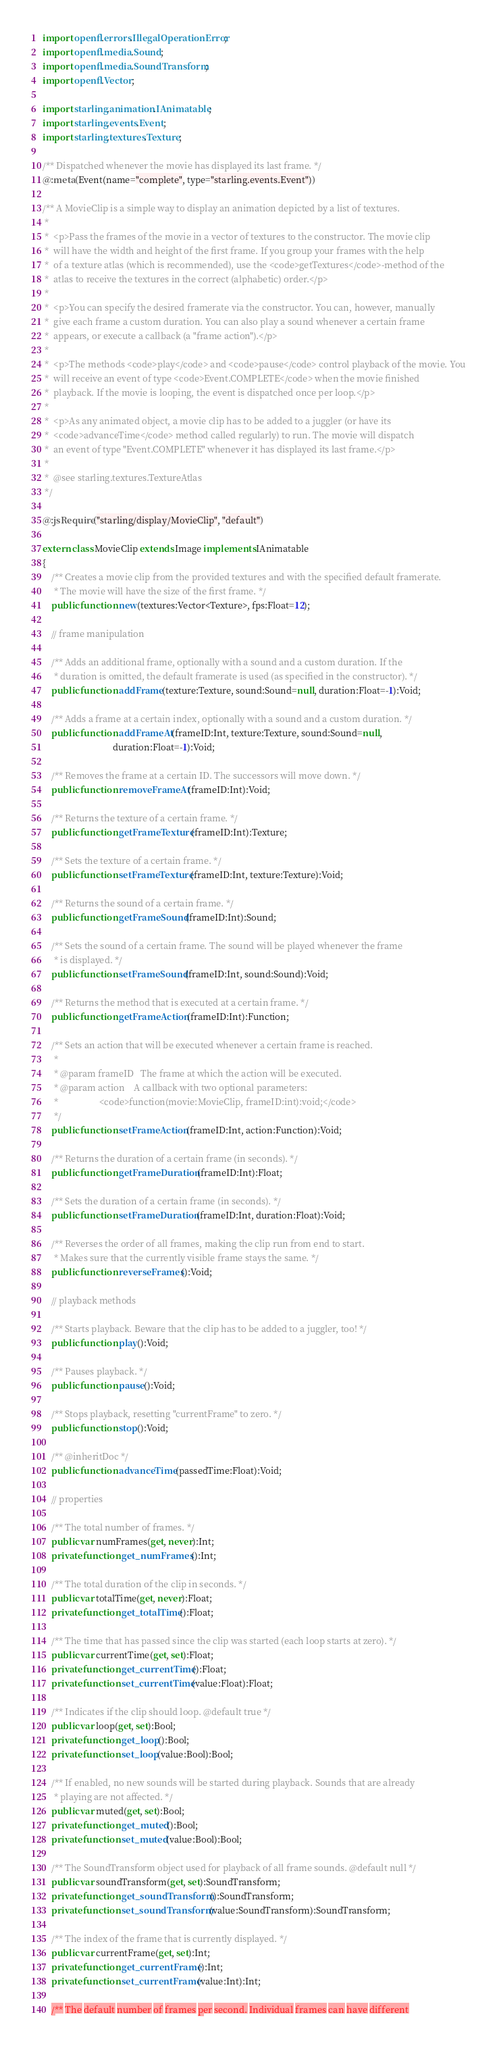<code> <loc_0><loc_0><loc_500><loc_500><_Haxe_>import openfl.errors.IllegalOperationError;
import openfl.media.Sound;
import openfl.media.SoundTransform;
import openfl.Vector;

import starling.animation.IAnimatable;
import starling.events.Event;
import starling.textures.Texture;

/** Dispatched whenever the movie has displayed its last frame. */
@:meta(Event(name="complete", type="starling.events.Event"))

/** A MovieClip is a simple way to display an animation depicted by a list of textures.
 *  
 *  <p>Pass the frames of the movie in a vector of textures to the constructor. The movie clip 
 *  will have the width and height of the first frame. If you group your frames with the help 
 *  of a texture atlas (which is recommended), use the <code>getTextures</code>-method of the 
 *  atlas to receive the textures in the correct (alphabetic) order.</p> 
 *  
 *  <p>You can specify the desired framerate via the constructor. You can, however, manually 
 *  give each frame a custom duration. You can also play a sound whenever a certain frame 
 *  appears, or execute a callback (a "frame action").</p>
 *  
 *  <p>The methods <code>play</code> and <code>pause</code> control playback of the movie. You
 *  will receive an event of type <code>Event.COMPLETE</code> when the movie finished
 *  playback. If the movie is looping, the event is dispatched once per loop.</p>
 *  
 *  <p>As any animated object, a movie clip has to be added to a juggler (or have its 
 *  <code>advanceTime</code> method called regularly) to run. The movie will dispatch 
 *  an event of type "Event.COMPLETE" whenever it has displayed its last frame.</p>
 *  
 *  @see starling.textures.TextureAtlas
 */    

@:jsRequire("starling/display/MovieClip", "default")

extern class MovieClip extends Image implements IAnimatable
{
    /** Creates a movie clip from the provided textures and with the specified default framerate.
     * The movie will have the size of the first frame. */  
    public function new(textures:Vector<Texture>, fps:Float=12);
    
    // frame manipulation
    
    /** Adds an additional frame, optionally with a sound and a custom duration. If the 
     * duration is omitted, the default framerate is used (as specified in the constructor). */   
    public function addFrame(texture:Texture, sound:Sound=null, duration:Float=-1):Void;
    
    /** Adds a frame at a certain index, optionally with a sound and a custom duration. */
    public function addFrameAt(frameID:Int, texture:Texture, sound:Sound=null, 
                               duration:Float=-1):Void;
    
    /** Removes the frame at a certain ID. The successors will move down. */
    public function removeFrameAt(frameID:Int):Void;
    
    /** Returns the texture of a certain frame. */
    public function getFrameTexture(frameID:Int):Texture;
    
    /** Sets the texture of a certain frame. */
    public function setFrameTexture(frameID:Int, texture:Texture):Void;
    
    /** Returns the sound of a certain frame. */
    public function getFrameSound(frameID:Int):Sound;
    
    /** Sets the sound of a certain frame. The sound will be played whenever the frame 
     * is displayed. */
    public function setFrameSound(frameID:Int, sound:Sound):Void;

    /** Returns the method that is executed at a certain frame. */
    public function getFrameAction(frameID:Int):Function;

    /** Sets an action that will be executed whenever a certain frame is reached.
     *
     * @param frameID   The frame at which the action will be executed.
     * @param action    A callback with two optional parameters:
     *                  <code>function(movie:MovieClip, frameID:int):void;</code>
     */
    public function setFrameAction(frameID:Int, action:Function):Void;
    
    /** Returns the duration of a certain frame (in seconds). */
    public function getFrameDuration(frameID:Int):Float;
    
    /** Sets the duration of a certain frame (in seconds). */
    public function setFrameDuration(frameID:Int, duration:Float):Void;

    /** Reverses the order of all frames, making the clip run from end to start.
     * Makes sure that the currently visible frame stays the same. */
    public function reverseFrames():Void;
    
    // playback methods
    
    /** Starts playback. Beware that the clip has to be added to a juggler, too! */
    public function play():Void;
    
    /** Pauses playback. */
    public function pause():Void;
    
    /** Stops playback, resetting "currentFrame" to zero. */
    public function stop():Void;

    /** @inheritDoc */
    public function advanceTime(passedTime:Float):Void;
    
    // properties

    /** The total number of frames. */
    public var numFrames(get, never):Int;
    private function get_numFrames():Int;
    
    /** The total duration of the clip in seconds. */
    public var totalTime(get, never):Float;
    private function get_totalTime():Float;
    
    /** The time that has passed since the clip was started (each loop starts at zero). */
    public var currentTime(get, set):Float;
    private function get_currentTime():Float;
    private function set_currentTime(value:Float):Float;

    /** Indicates if the clip should loop. @default true */
    public var loop(get, set):Bool;
    private function get_loop():Bool;
    private function set_loop(value:Bool):Bool;
    
    /** If enabled, no new sounds will be started during playback. Sounds that are already
     * playing are not affected. */
    public var muted(get, set):Bool;
    private function get_muted():Bool;
    private function set_muted(value:Bool):Bool;

    /** The SoundTransform object used for playback of all frame sounds. @default null */
    public var soundTransform(get, set):SoundTransform;
    private function get_soundTransform():SoundTransform;
    private function set_soundTransform(value:SoundTransform):SoundTransform;

    /** The index of the frame that is currently displayed. */
    public var currentFrame(get, set):Int;
    private function get_currentFrame():Int;
    private function set_currentFrame(value:Int):Int;
    
    /** The default number of frames per second. Individual frames can have different </code> 